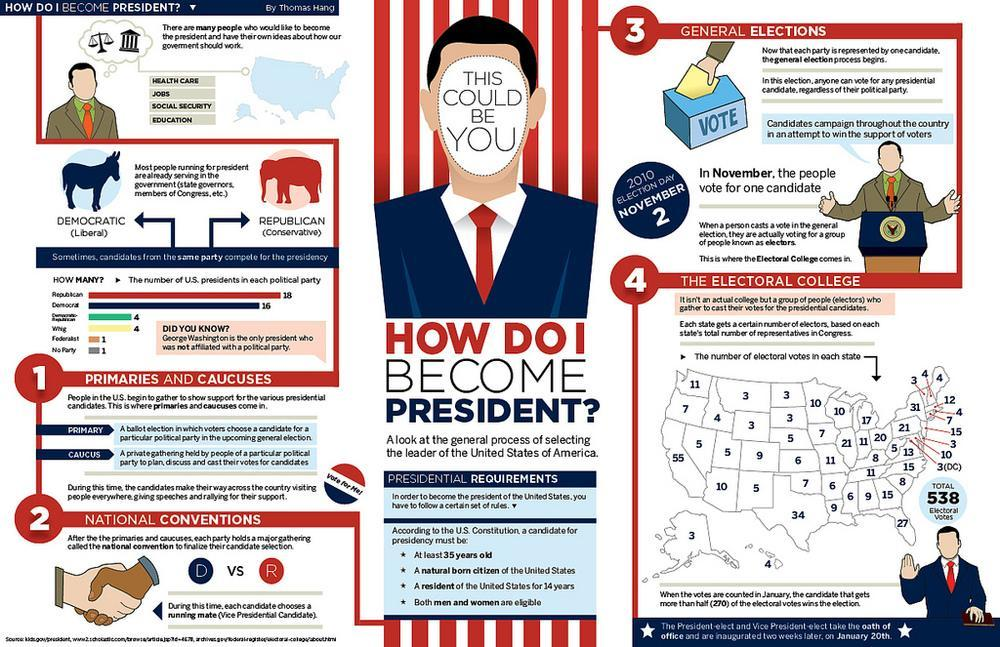What is the age criteria of a candidate for presidency according to the U.S. Constitution?
Answer the question with a short phrase. Atleast 35 years old How many years of U.S. residency is mandatory for a presidential candidature according to the U.S. constitution? 14 Who is the only U.S.president who was not affilliated with a political party? George Washington Which political party in U.S. had the most number of Presidents? Republican Which are the two prominent political parties in the U.S.? Democratic, Republican 